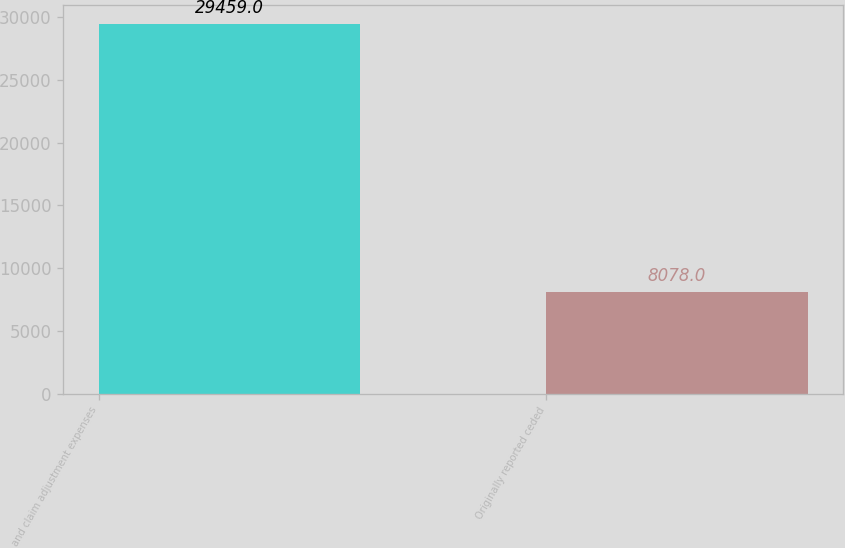Convert chart. <chart><loc_0><loc_0><loc_500><loc_500><bar_chart><fcel>and claim adjustment expenses<fcel>Originally reported ceded<nl><fcel>29459<fcel>8078<nl></chart> 